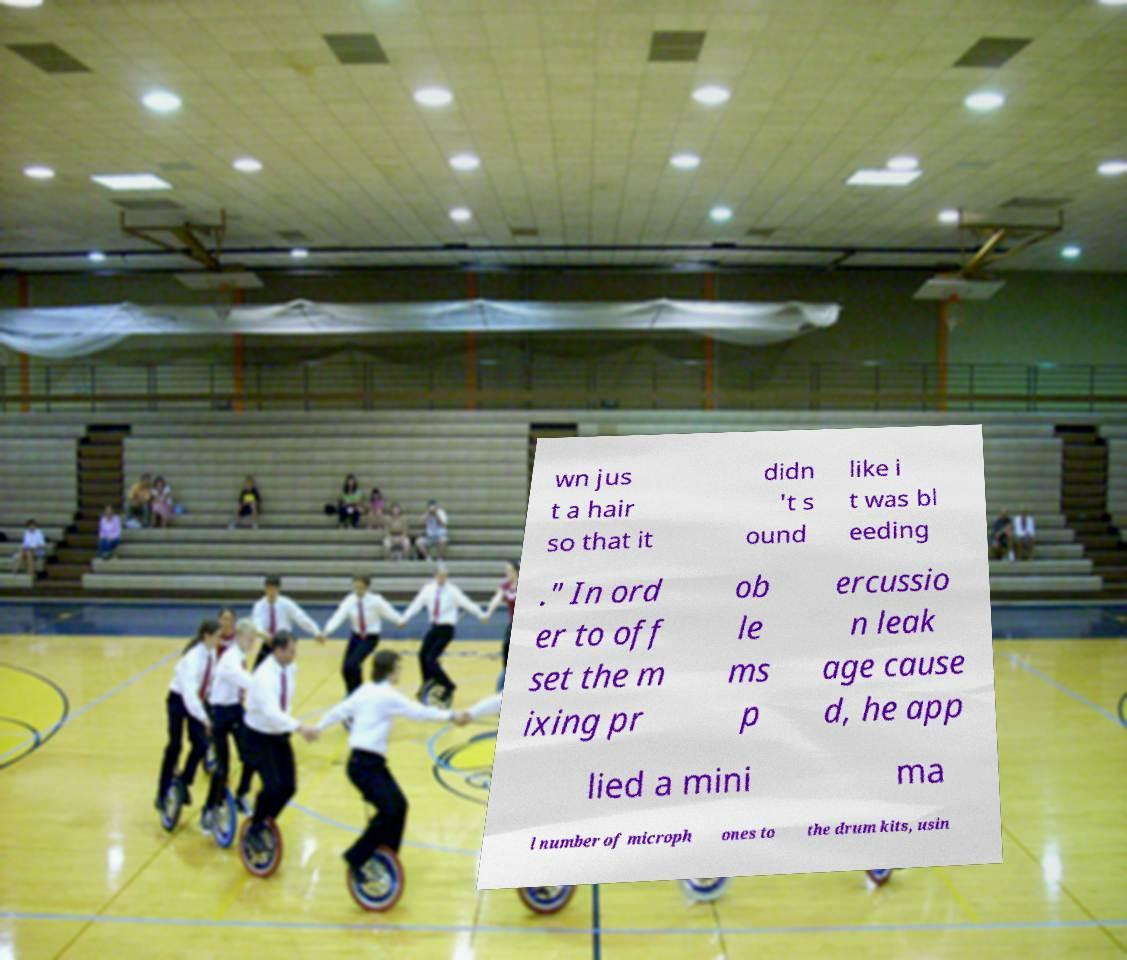There's text embedded in this image that I need extracted. Can you transcribe it verbatim? wn jus t a hair so that it didn 't s ound like i t was bl eeding ." In ord er to off set the m ixing pr ob le ms p ercussio n leak age cause d, he app lied a mini ma l number of microph ones to the drum kits, usin 